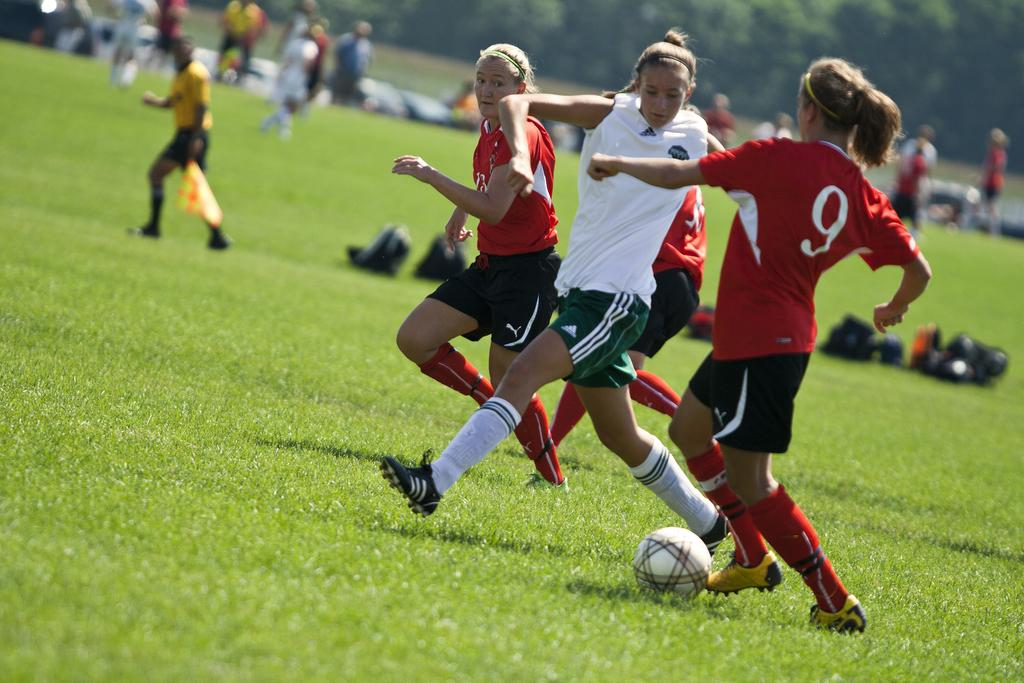Provide a one-sentence caption for the provided image. Player number 9 kicks the ball down the field away from her opponent. 